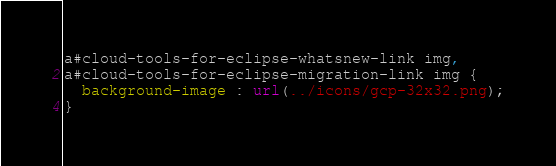Convert code to text. <code><loc_0><loc_0><loc_500><loc_500><_CSS_>a#cloud-tools-for-eclipse-whatsnew-link img,
a#cloud-tools-for-eclipse-migration-link img {
  background-image : url(../icons/gcp-32x32.png);
}</code> 